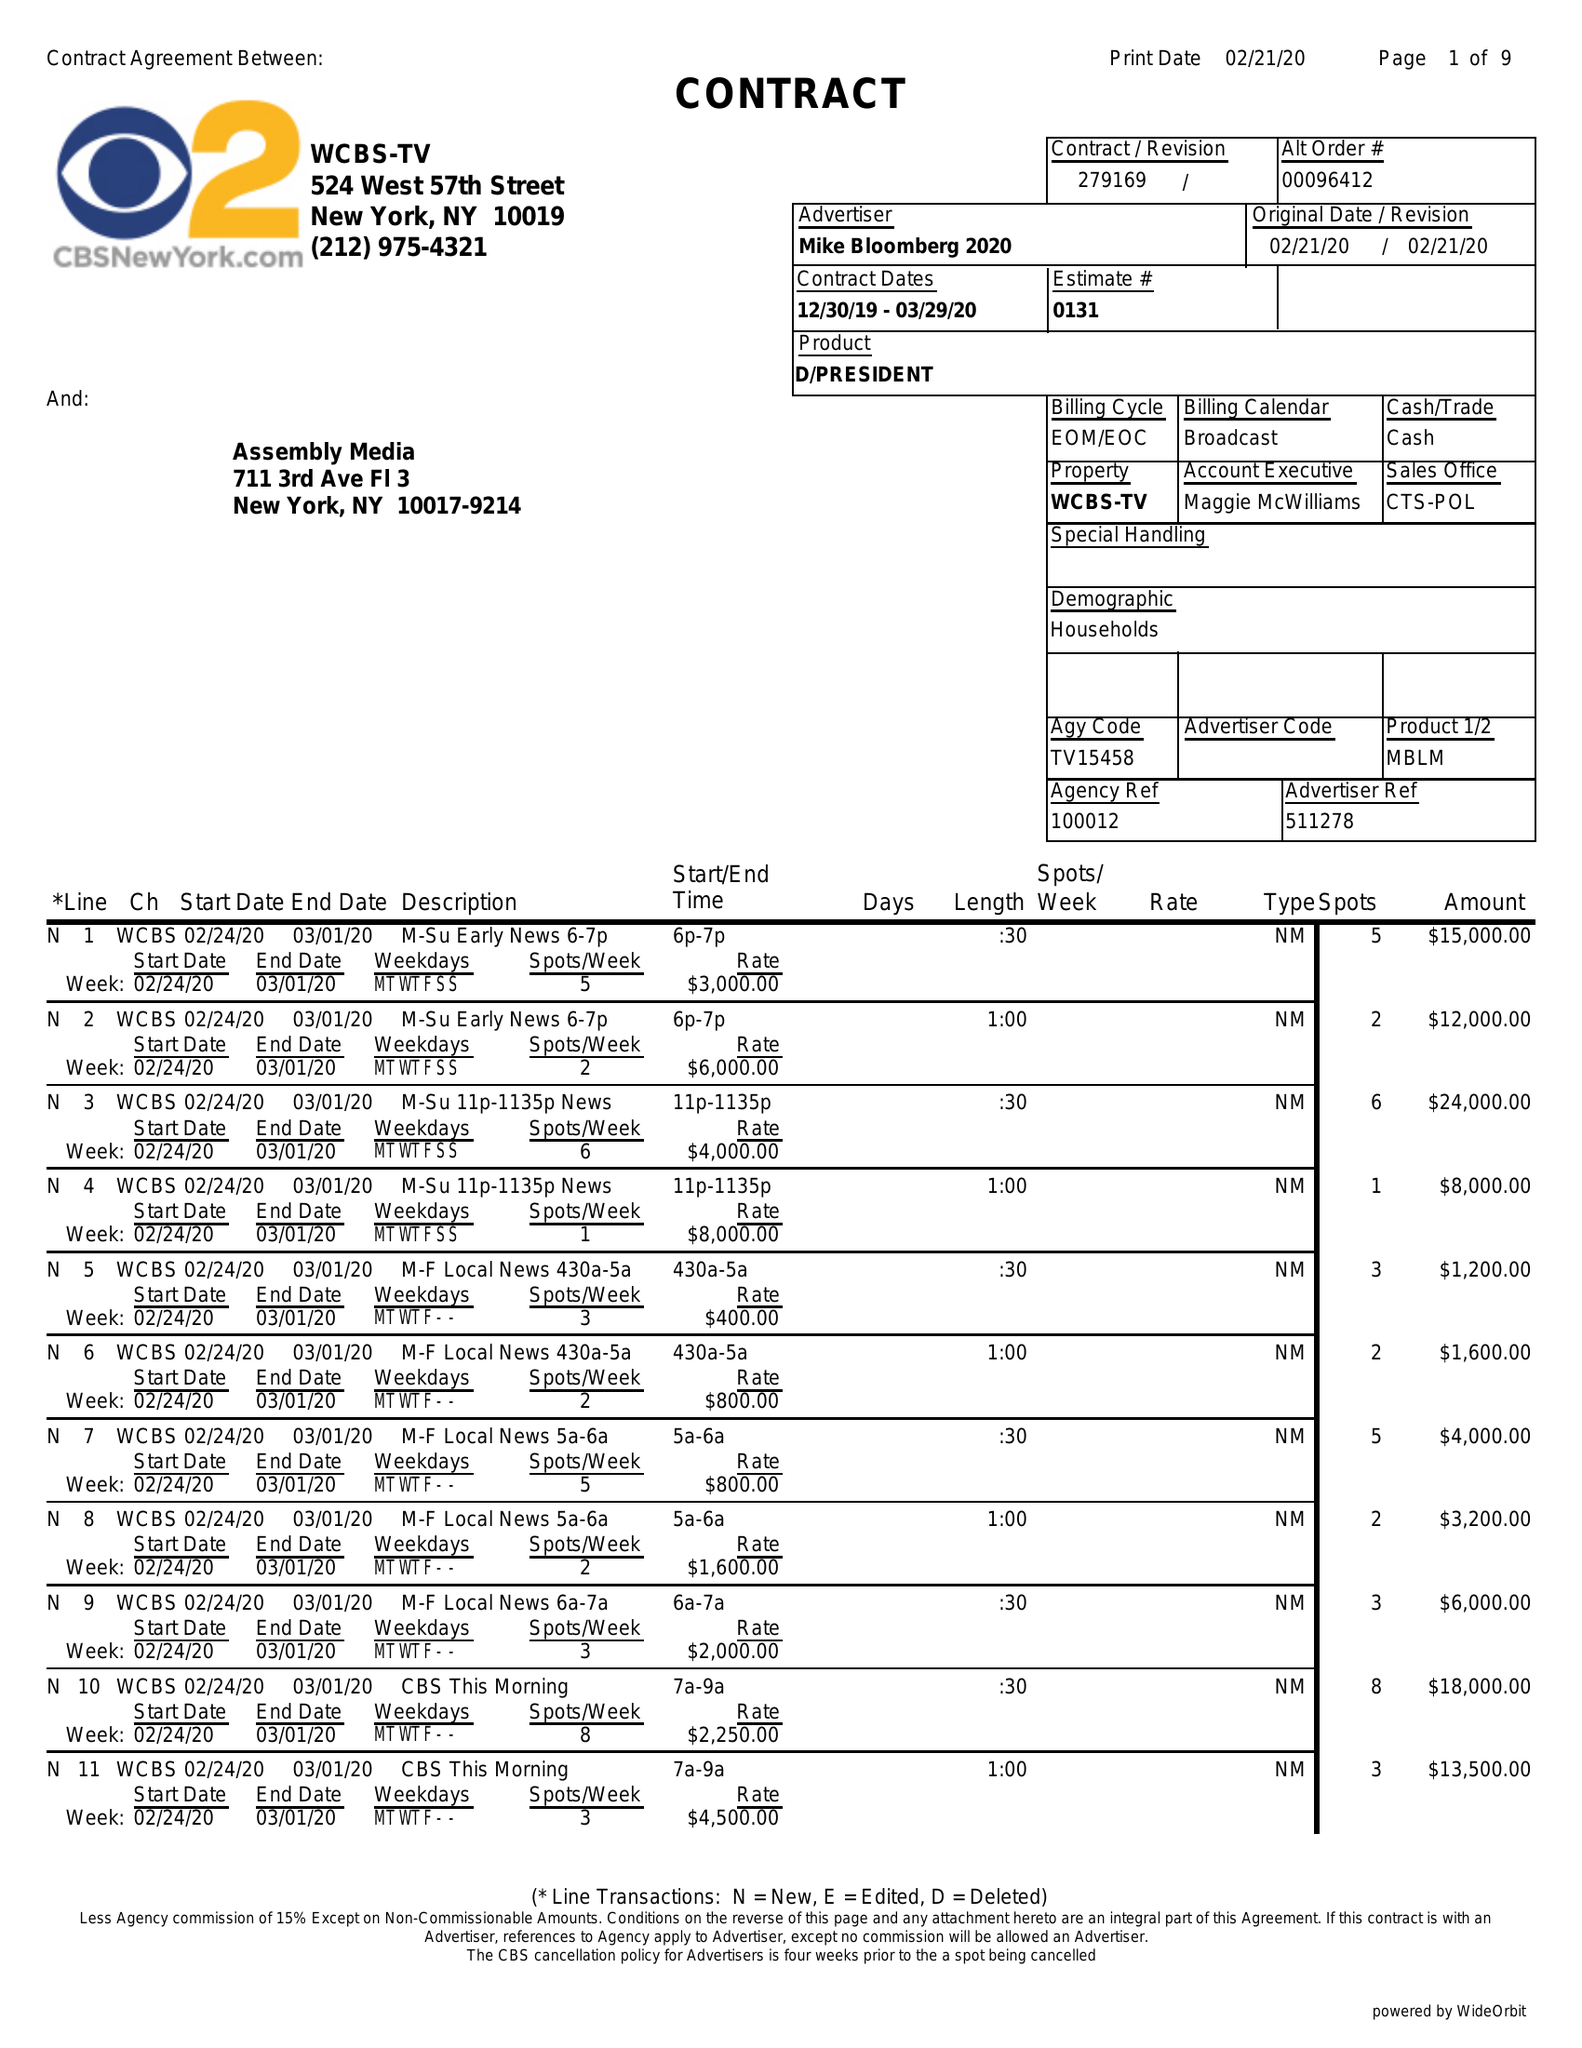What is the value for the gross_amount?
Answer the question using a single word or phrase. 823000.00 